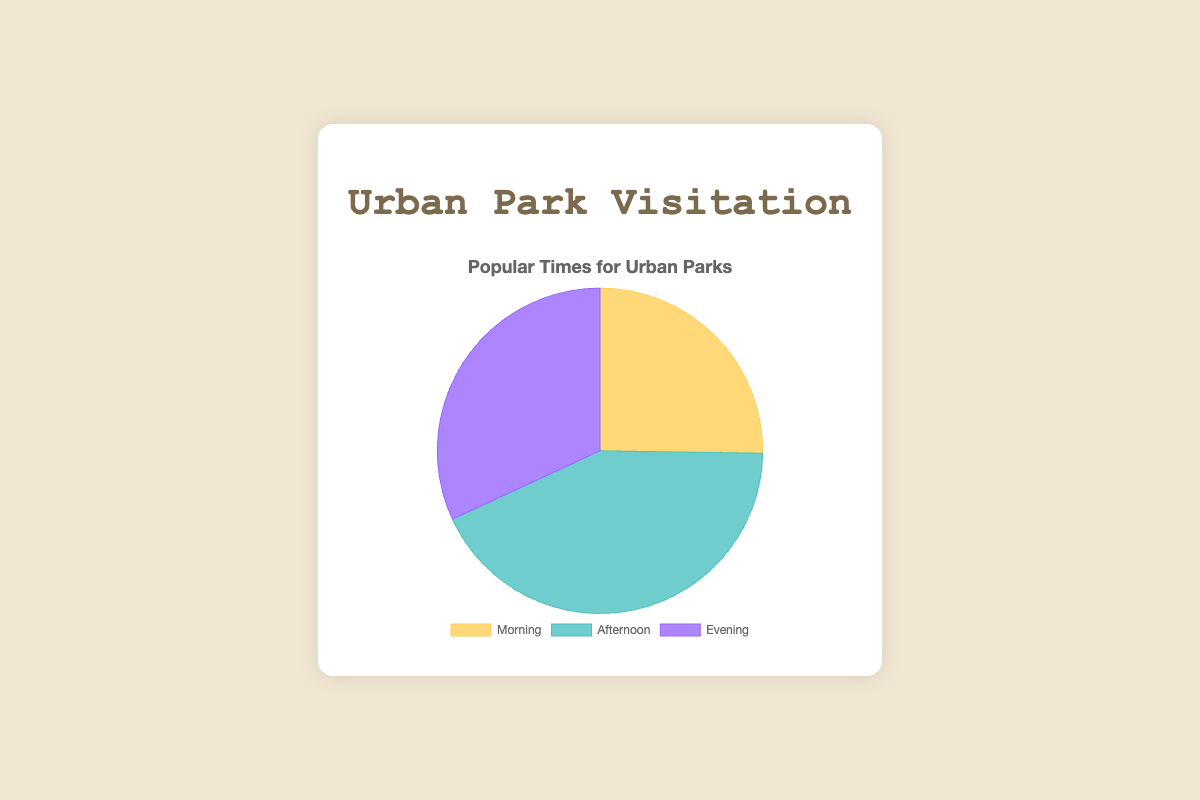What's the most popular time for visiting urban parks? The pie chart shows three different times of day with their respective visitation numbers: Morning (530), Afternoon (900), and Evening (670). The section with the largest value represents the most popular time.
Answer: Afternoon What is the difference in visitor numbers between Morning and Evening? To find the difference, subtract the number of visitors for the Morning (530) from the number of visitors for the Evening (670). Calculation: 670 - 530
Answer: 140 Which time has the least number of visitors? The pie chart shows three data points: Morning (530), Afternoon (900), and Evening (670). The smallest value among these is for the Morning visitors.
Answer: Morning By how much do Afternoon visitors exceed Morning visitors? To determine how much Afternoon visitors exceed Morning visitors, subtract the number of Morning visitors (530) from the number of Afternoon visitors (900). Calculation: 900 - 530
Answer: 370 What fraction of the total visitors come in the Evening? First, find the total number of visitors by summing the three categories: Morning (530), Afternoon (900), and Evening (670). Total: 530 + 900 + 670 = 2100. The fraction of Evening visitors is then the number of Evening visitors (670) divided by the total number of visitors (2100). Calculation: 670 / 2100.
Answer: 670/2100 Which time period is represented by the green section? The chart uses colors to represent different times: Morning, Afternoon, and Evening. The green section corresponds to the Afternoon time period.
Answer: Afternoon How many visitors are there in total? Add the number of visitors for each time period to get the total number: Morning (530) + Afternoon (900) + Evening (670). Calculation: 530 + 900 + 670
Answer: 2100 Compare the sum of Morning and Evening visitors to the number of Afternoon visitors. Which is greater? First, calculate the sum of Morning (530) and Evening (670) visitors: 530 + 670 = 1200. The number of Afternoon visitors is 900. Since 1200 is greater than 900, the sum of Morning and Evening visitors is greater.
Answer: Morning + Evening What is the ratio of Afternoon to Evening visitors? To get the ratio, divide the number of Afternoon visitors (900) by the number of Evening visitors (670). Calculation: 900 / 670
Answer: 900:670 